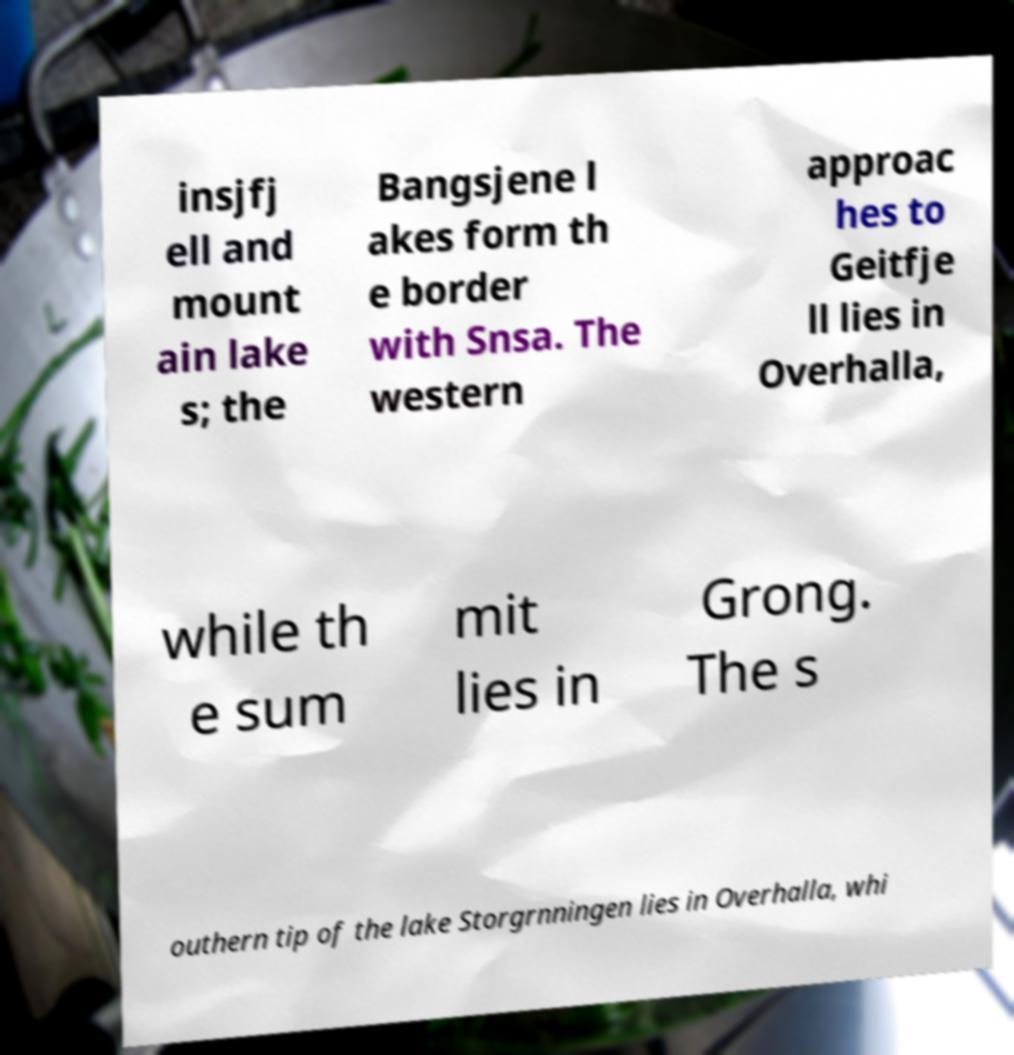Could you assist in decoding the text presented in this image and type it out clearly? insjfj ell and mount ain lake s; the Bangsjene l akes form th e border with Snsa. The western approac hes to Geitfje ll lies in Overhalla, while th e sum mit lies in Grong. The s outhern tip of the lake Storgrnningen lies in Overhalla, whi 